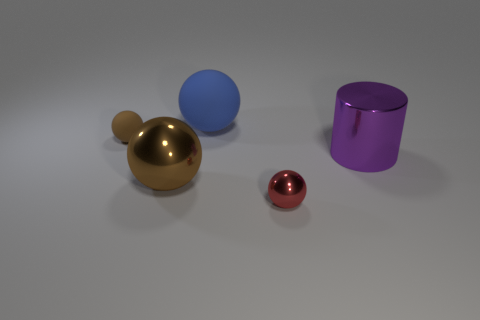Subtract all yellow cylinders. Subtract all gray balls. How many cylinders are left? 1 Subtract all blue cylinders. How many red balls are left? 1 Add 4 tiny blues. How many tiny things exist? 0 Subtract all big purple metallic objects. Subtract all blue balls. How many objects are left? 3 Add 1 purple objects. How many purple objects are left? 2 Add 2 large green rubber objects. How many large green rubber objects exist? 2 Add 4 purple metal things. How many objects exist? 9 Subtract all blue balls. How many balls are left? 3 Subtract all red shiny spheres. How many spheres are left? 3 Subtract 0 cyan cylinders. How many objects are left? 5 